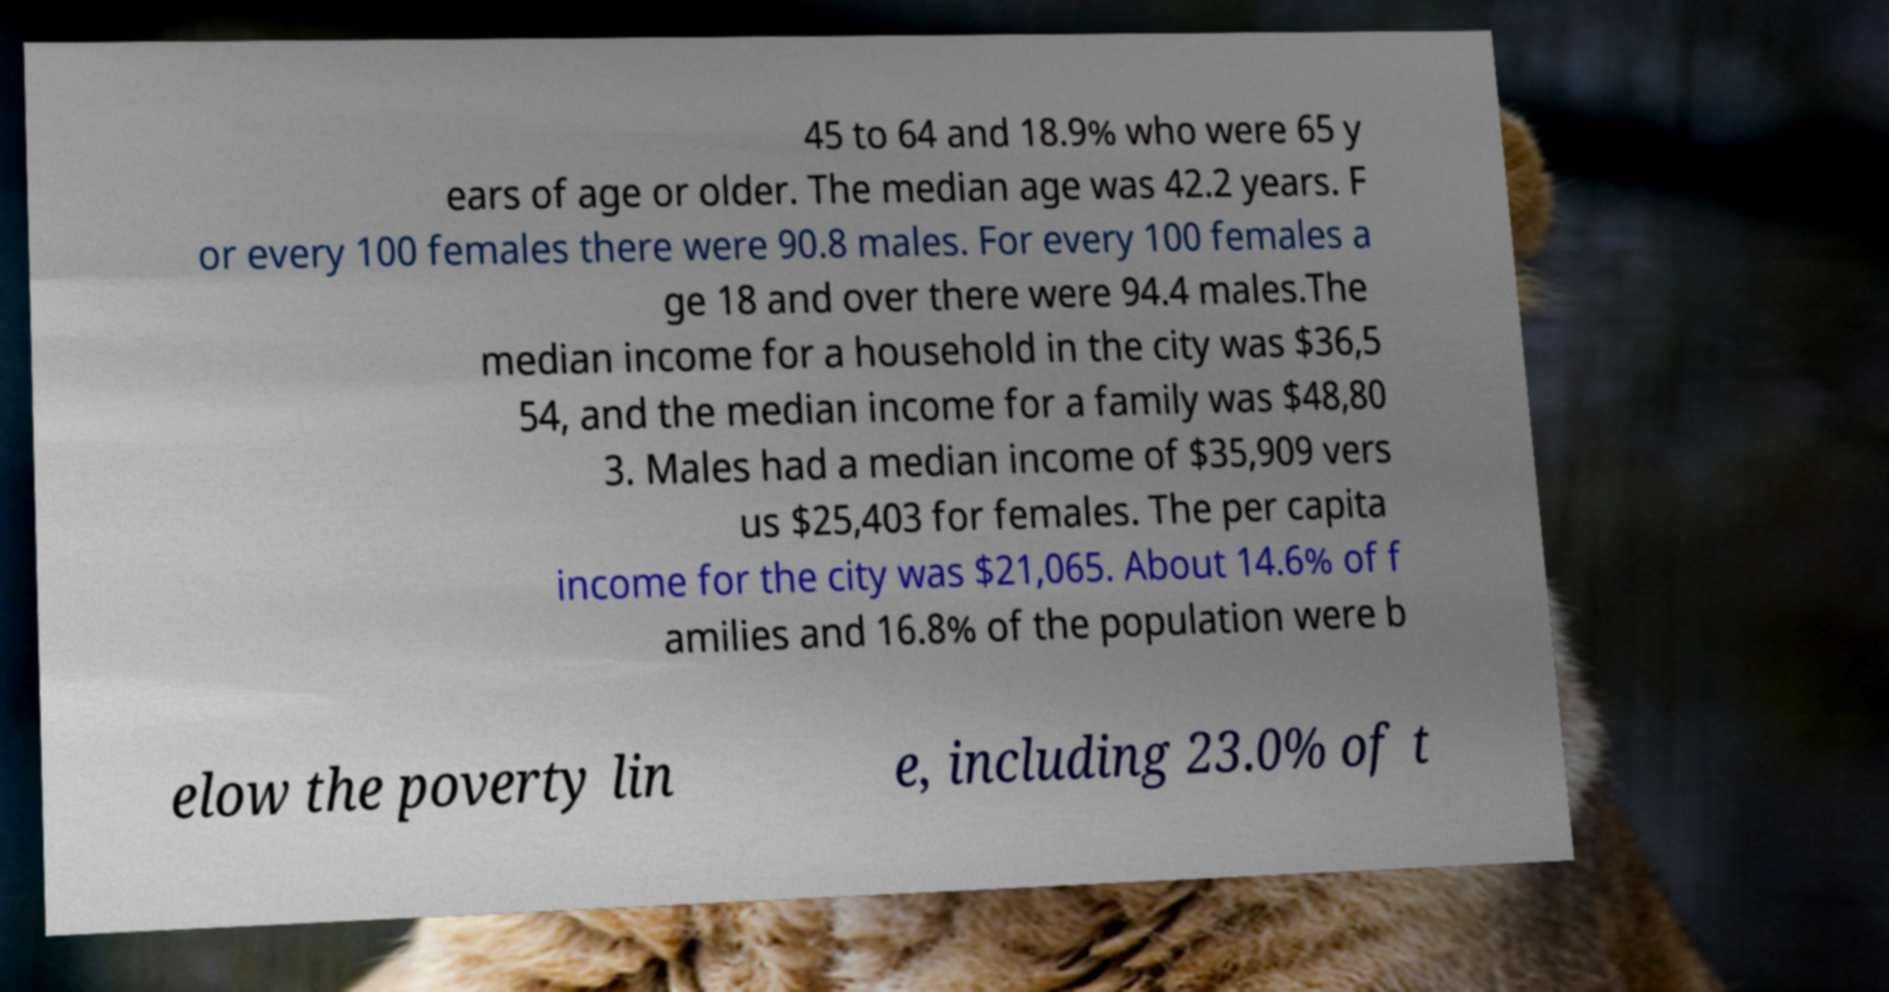For documentation purposes, I need the text within this image transcribed. Could you provide that? 45 to 64 and 18.9% who were 65 y ears of age or older. The median age was 42.2 years. F or every 100 females there were 90.8 males. For every 100 females a ge 18 and over there were 94.4 males.The median income for a household in the city was $36,5 54, and the median income for a family was $48,80 3. Males had a median income of $35,909 vers us $25,403 for females. The per capita income for the city was $21,065. About 14.6% of f amilies and 16.8% of the population were b elow the poverty lin e, including 23.0% of t 